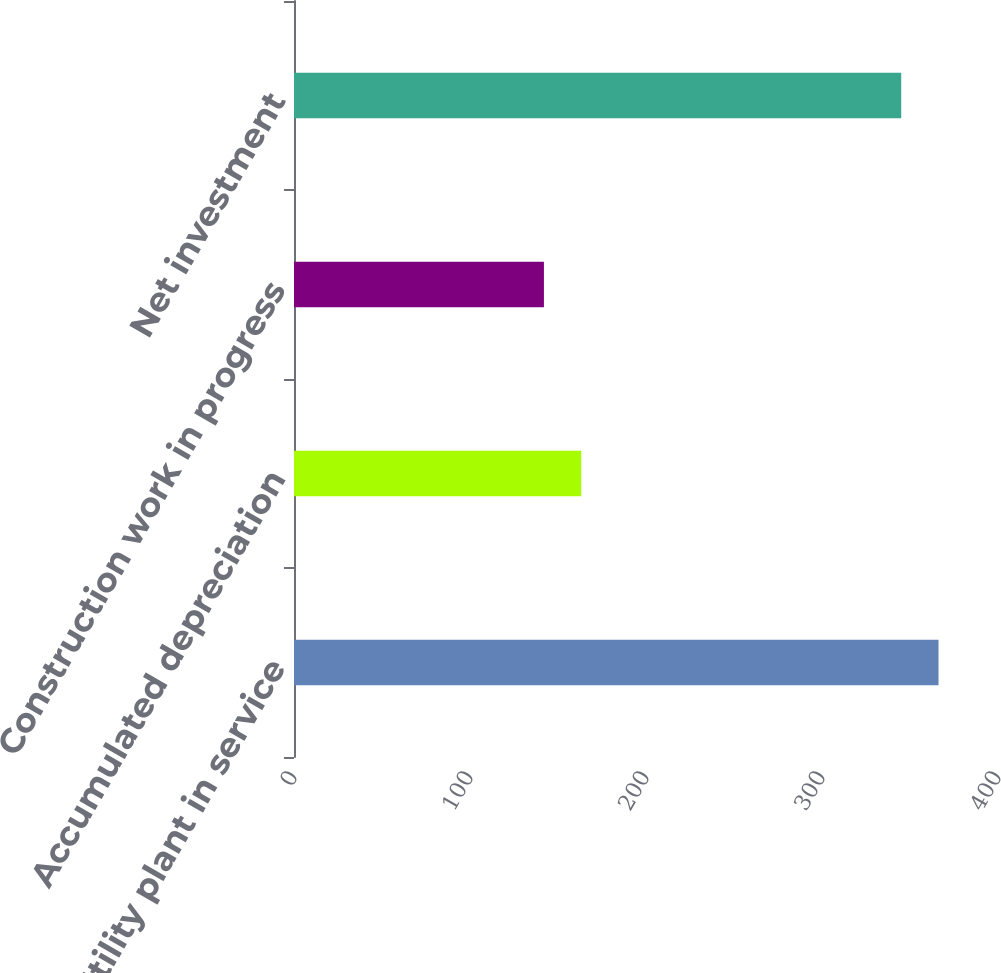Convert chart to OTSL. <chart><loc_0><loc_0><loc_500><loc_500><bar_chart><fcel>Utility plant in service<fcel>Accumulated depreciation<fcel>Construction work in progress<fcel>Net investment<nl><fcel>366.2<fcel>163.2<fcel>142<fcel>345<nl></chart> 